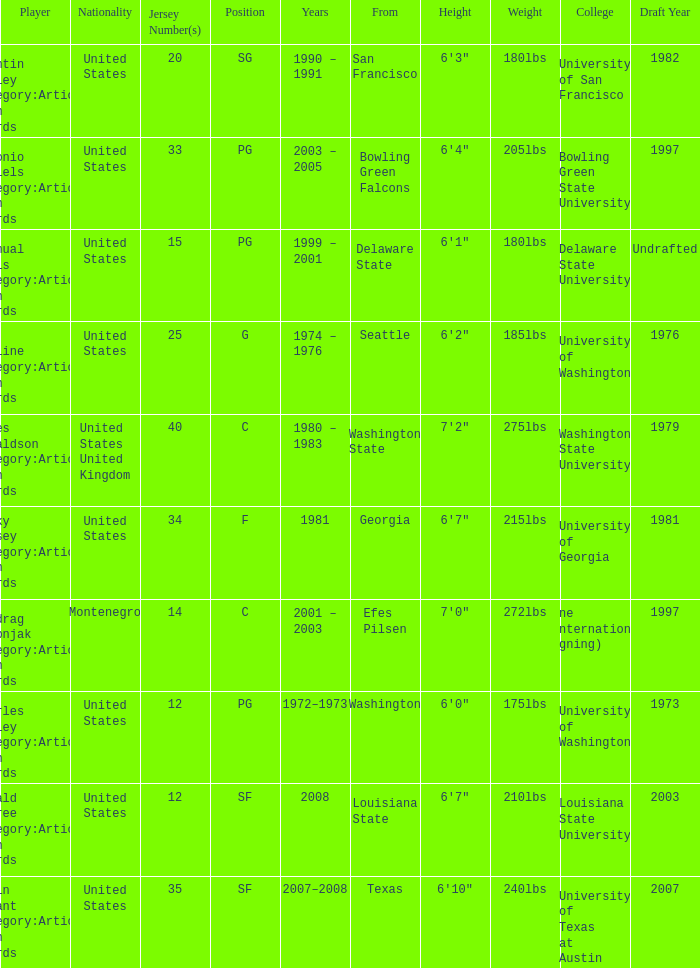What college was the player with the jersey number of 34 from? Georgia. 